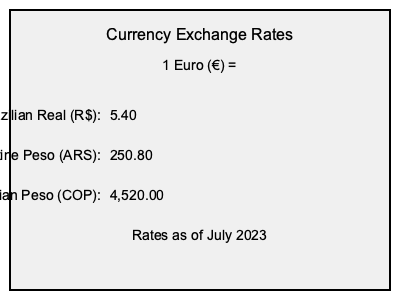You've just signed a contract with a top European club for €2,500,000 per year. Your family in Colombia wants to know how much this is in Colombian Pesos (COP). Based on the exchange rates provided, how many Colombian Pesos will your annual salary be worth? To solve this problem, we'll follow these steps:

1. Identify the given information:
   - Annual salary: €2,500,000
   - Exchange rate: 1 Euro (€) = 4,520.00 Colombian Pesos (COP)

2. Set up the conversion:
   We need to multiply the salary in Euros by the exchange rate to get the amount in Colombian Pesos.

3. Perform the calculation:
   $2,500,000 \times 4,520.00 = 11,300,000,000$

4. Format the result:
   In Colombia, large numbers are typically separated by periods for thousands and commas for decimals.

Therefore, your annual salary of €2,500,000 is equivalent to COP 11.300.000.000,00.
Answer: COP 11.300.000.000,00 